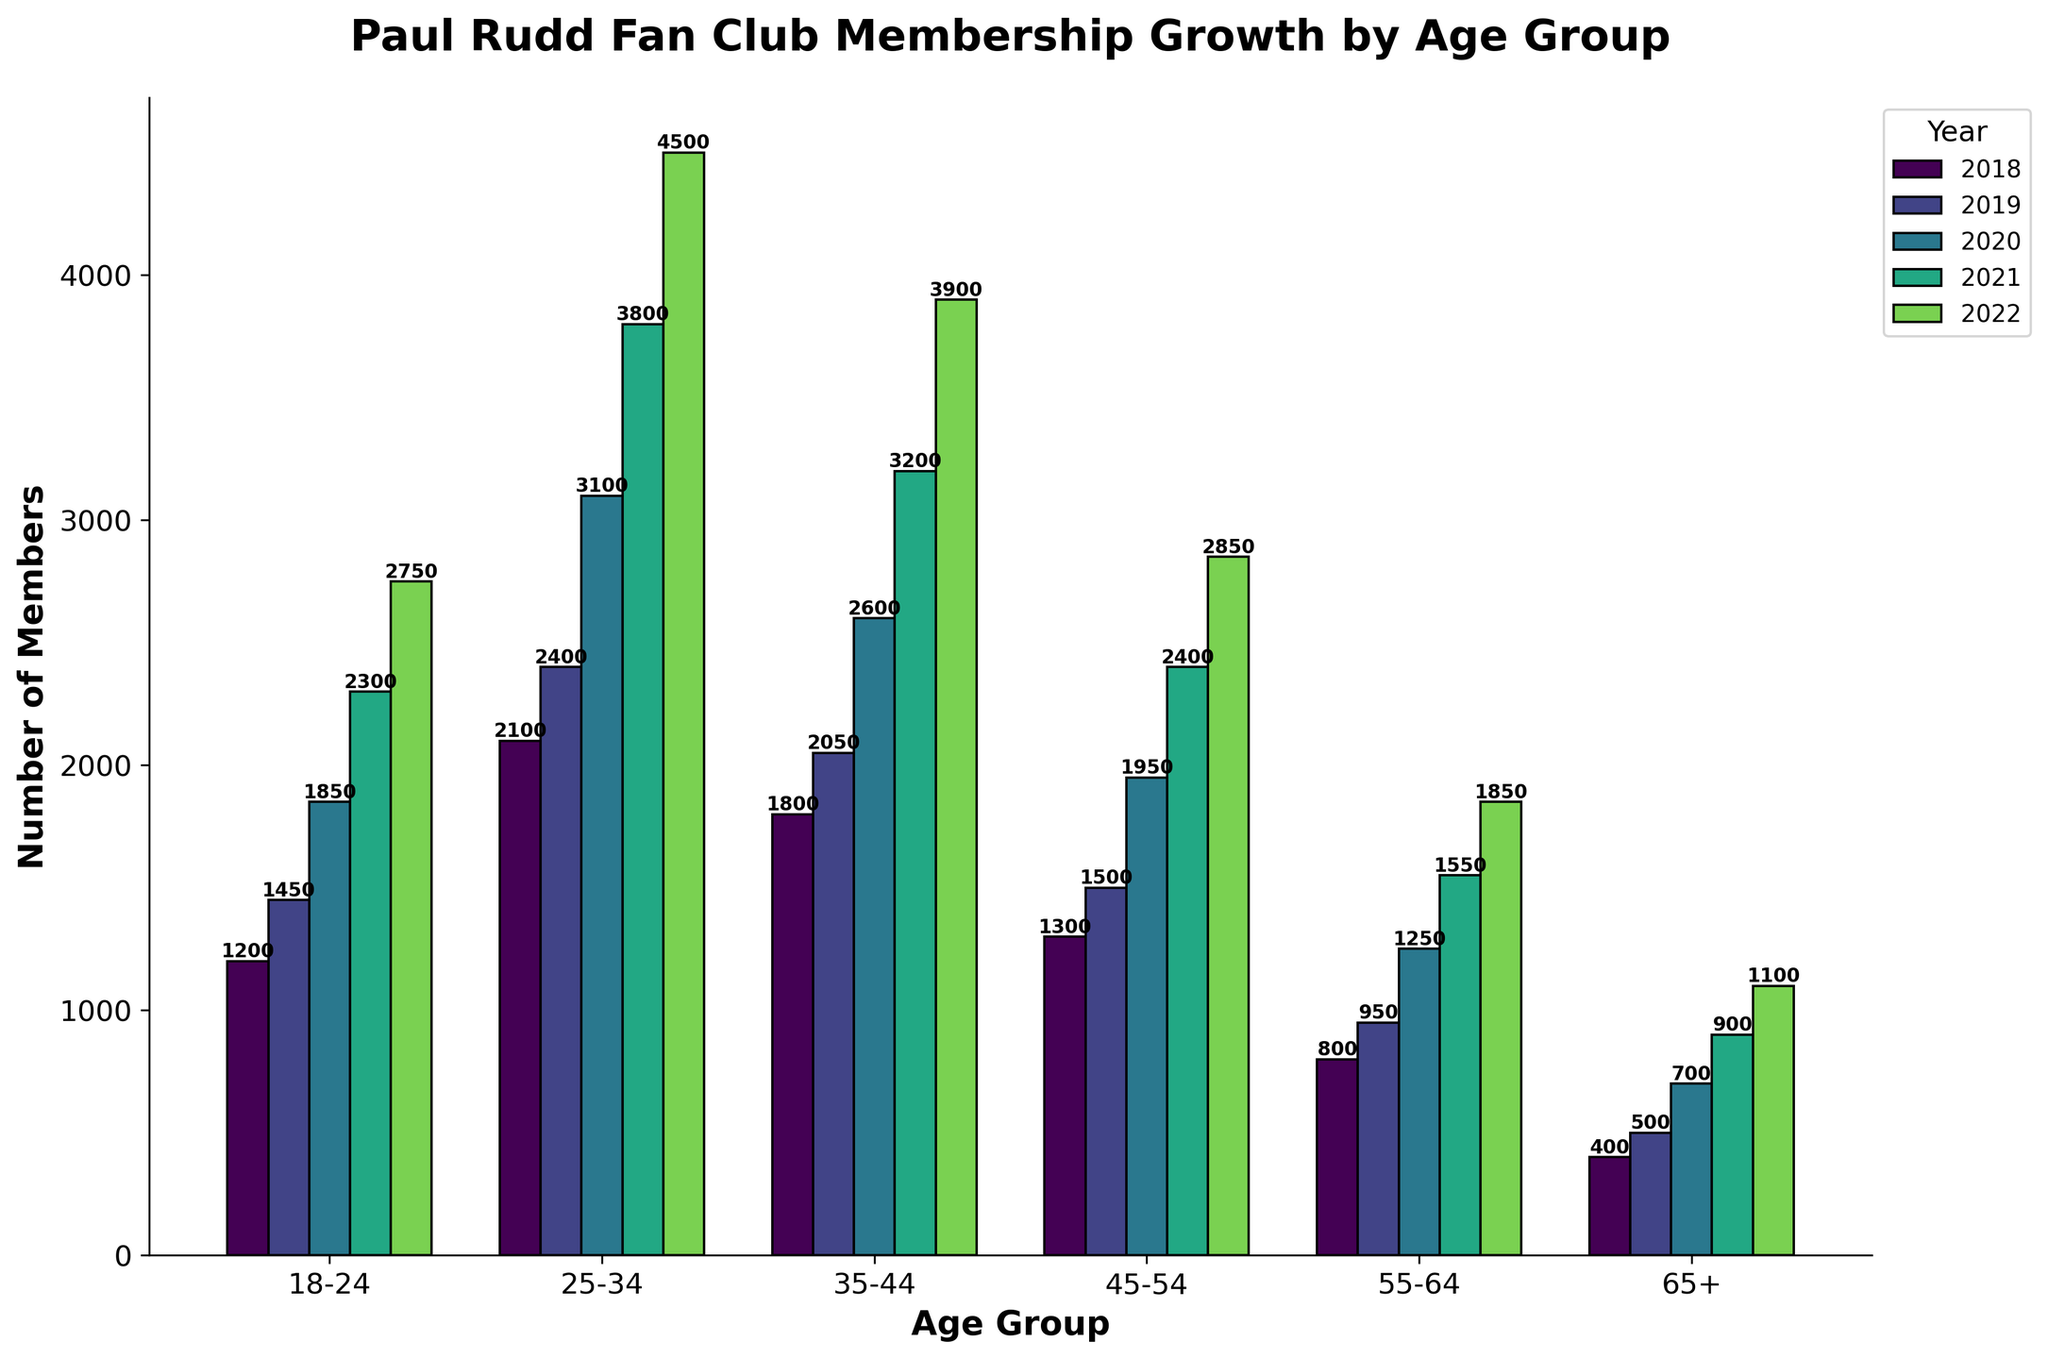Which age group had the highest membership growth in 2022? The bars in the chart represent different age groups, and we can see which bar was the tallest for 2022. The age group 25-34 had the highest bar in 2022.
Answer: 25-34 How many total members were in the 18-24 age group across all 5 years? Add the membership numbers for the 18-24 age group: 1200 (2018) + 1450 (2019) + 1850 (2020) + 2300 (2021) + 2750 (2022) = 9550.
Answer: 9550 Which age group saw the smallest increase in membership from 2021 to 2022? For each age group, subtract the 2021 membership number from the 2022 number and find the smallest result: 
18-24: 2750 - 2300 = 450 
25-34: 4500 - 3800 = 700 
35-44: 3900 - 3200 = 700 
45-54: 2850 - 2400 = 450 
55-64: 1850 - 1550 = 300 
65+: 1100 - 900 = 200. 
The smallest increase is for age group 65+.
Answer: 65+ How did the membership of the 25-34 age group change from 2018 to 2019? Compare the 2018 and 2019 values for the 25-34 age group: 2400 (2019) - 2100 (2018) = 300.
Answer: Increased by 300 What was the average number of members in the 35-44 age group over the 5 years? Sum the numbers for the 35-44 age group and divide by 5: (1800 + 2050 + 2600 + 3200 + 3900) / 5 = 13550 / 5 = 2710.
Answer: 2710 Which two consecutive years had the largest increase in membership for any age group? Calculate the year-over-year increases for each age group and find the largest one:
18-24: 1450 - 1200 = 250, 1850 - 1450 = 400, 2300 - 1850 = 450, 2750 - 2300 = 450 
25-34: 2400 - 2100 = 300, 3100 - 2400 = 700, 3800 - 3100 = 700, 4500 - 3800 = 700 
35-44: 2050 - 1800 = 250, 2600 - 2050 = 550, 3200 - 2600 = 600, 3900 - 3200 = 700 
45-54: 1500 - 1300 = 200, 1950 - 1500 = 450, 2400 - 1950 = 450, 2850 - 2400 = 450 
55-64: 950 - 800 = 150, 1250 - 950 = 300, 1550 - 1250 = 300, 1850 - 1550 = 300 
65+: 500 - 400 = 100, 700 - 500 = 200, 900 - 700 = 200, 1100 - 900 = 200. 
The largest increase is for the 25-34 age group from 2019 to 2020, 700 members.
Answer: 2019 to 2020 